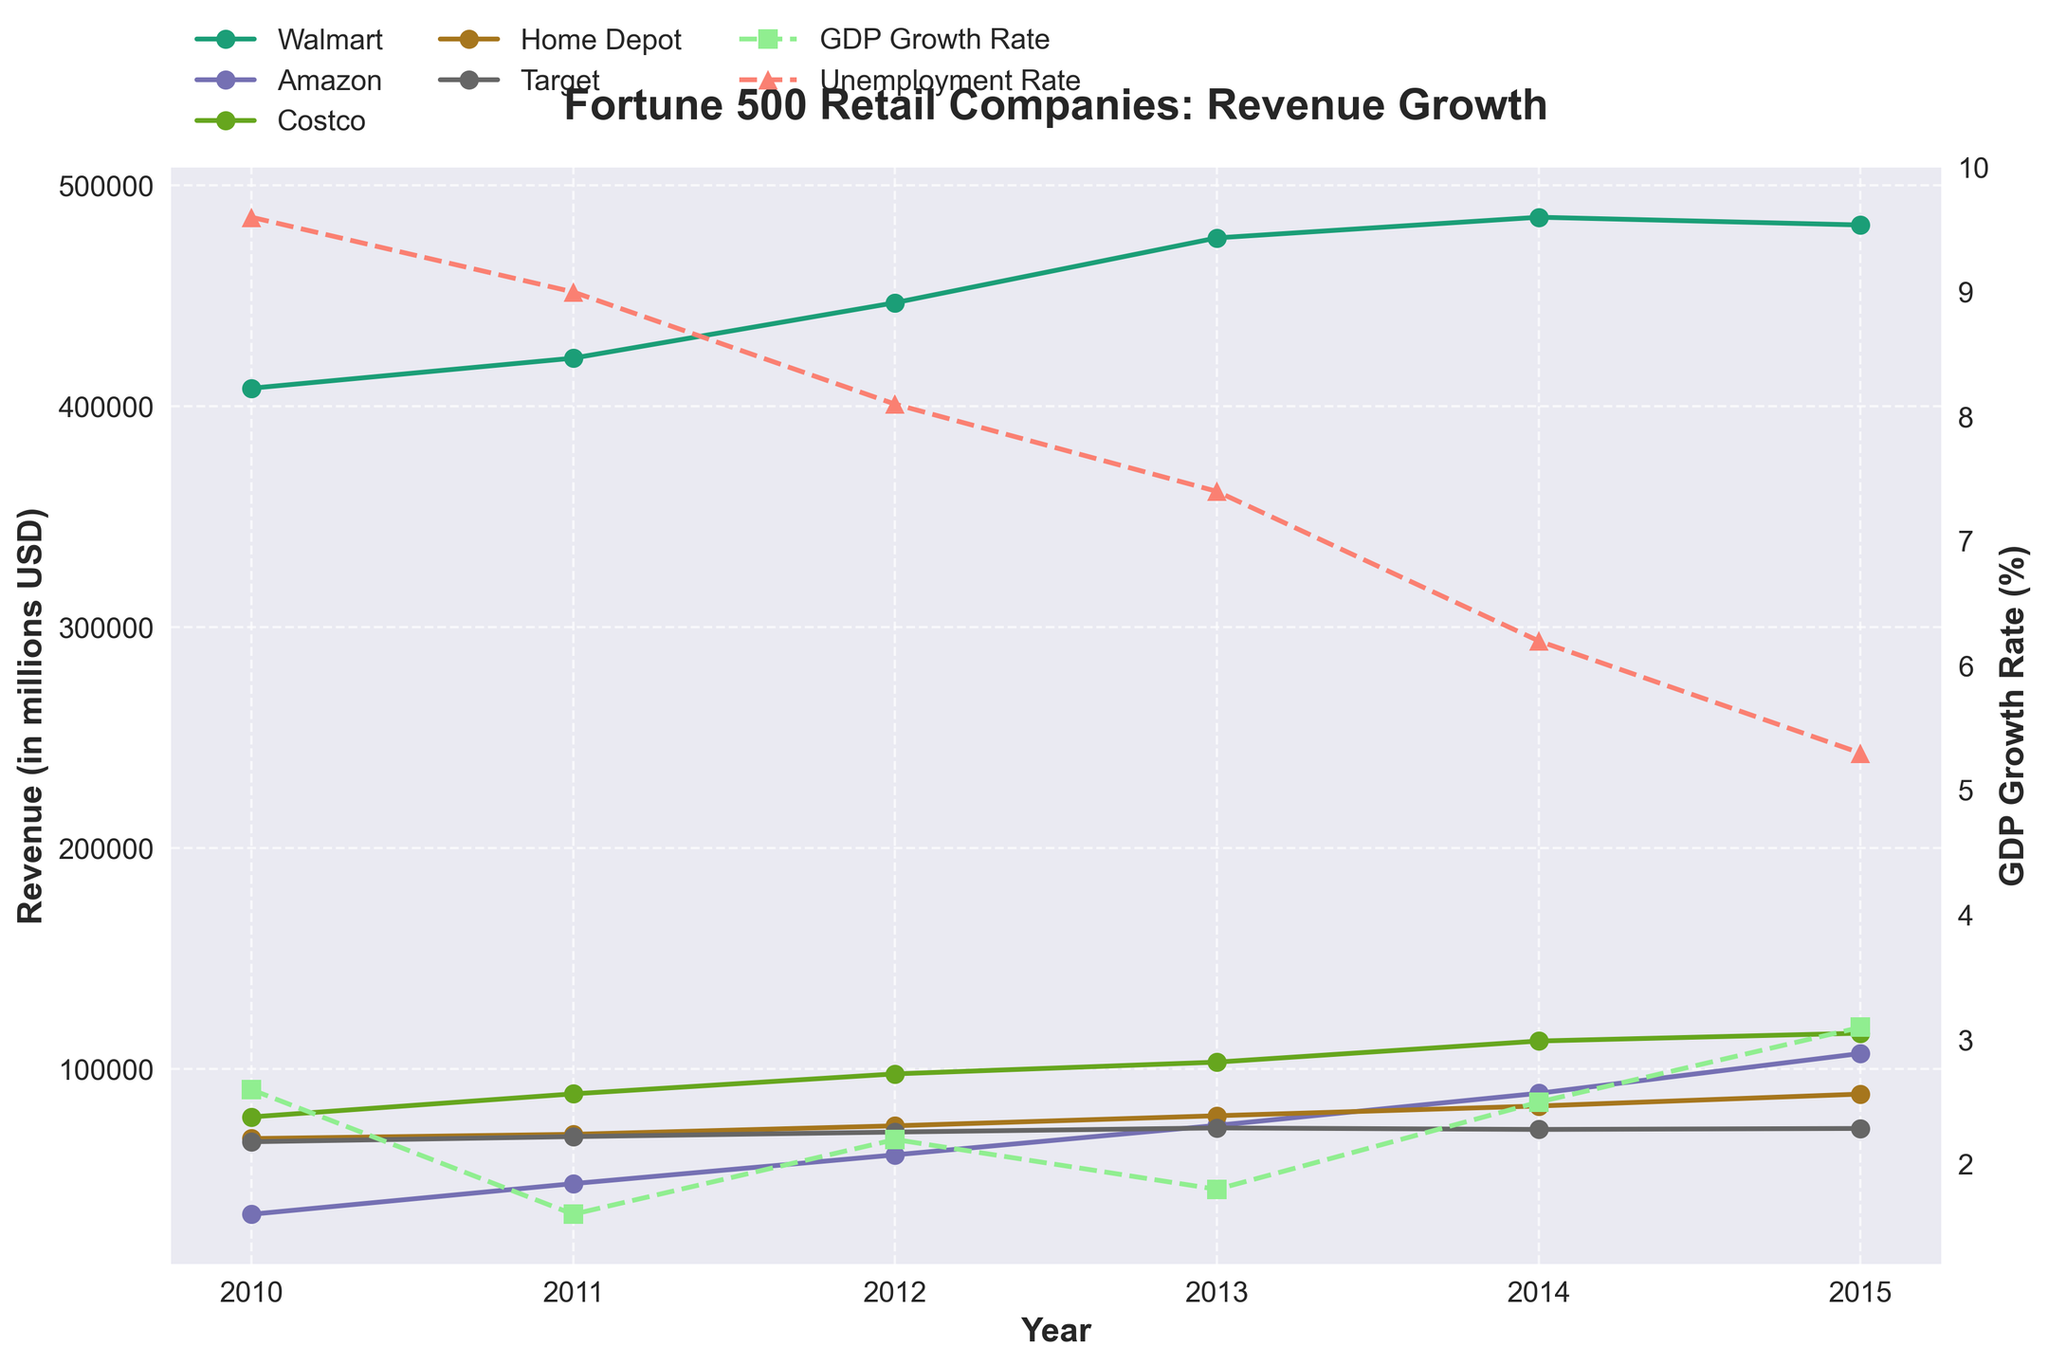What is the title of the plot? The title is shown prominently at the top of the plot. It reads "Fortune 500 Retail Companies: Revenue Growth."
Answer: Fortune 500 Retail Companies: Revenue Growth Which company had the highest revenue in 2014? By looking at the plot for the year 2014, Walmart's revenue is the highest among the companies shown.
Answer: Walmart How has Amazon's revenue changed from 2010 to 2015? Trace the Amazon data points from 2010 to 2015. The points show a continuous increase, moving from around $34,204 million in 2010 to $107,006 million in 2015.
Answer: Increased What trend do you observe in the GDP Growth Rate from 2010 to 2015? Observe the GDP growth line, which is marked with green and represented by squares. The GDP growth rate fluctuates, starting at 2.6% in 2010, dropping to 1.8% in 2013, and rising to 3.1% in 2015.
Answer: Fluctuating Which year had the lowest unemployment rate and what was it? Look at the red triangle markers (Unemployment Rate). The lowest unemployment rate, 5.3%, is in 2015.
Answer: 2015, 5.3% What is the revenue difference between Walmart and Target in 2012? Find Walmart's and Target's revenue in 2012. Walmart's revenue is $446,950 million and Target's revenue is $71,428 million. The difference is $446,950 million - $71,428 million = $375,522 million.
Answer: $375,522 million How does Costco's revenue growth rate compare to Home Depot's from 2010 to 2015? Examine the lines for both companies. Costco's revenue increases from $78,270 million to $116,199 million, and Home Depot's revenue increases from $68,480 million to $88,619 million. Both show growth, but Costco's revenue growth appears steeper.
Answer: Costco's revenue growth is steeper What is the relationship between the Unemployment Rate and GDP Growth Rate in the year 2011? Look at the markers for GDP Growth Rate and Unemployment Rate for 2011. GDP Growth Rate is at 1.6%, and Unemployment Rate is at 9.0%. As GDP growth is relatively low, unemployment remains high.
Answer: Low GDP Growth, High Unemployment Which company shows the most consistent revenue growth from 2010 to 2015? Examine the plotted lines for each company. Amazon's line shows the most consistent and continual ascent over the years without significant dips or plateaus.
Answer: Amazon Do the trends in the Fortune 500 companies' revenues correlate with the trends in the GDP growth rate? Compare the trends of the companies' revenues with the GDP growth rate line. Generally, when GDP growth rises, the revenues of most companies also increase, indicating a positive correlation.
Answer: Yes, positive correlation 